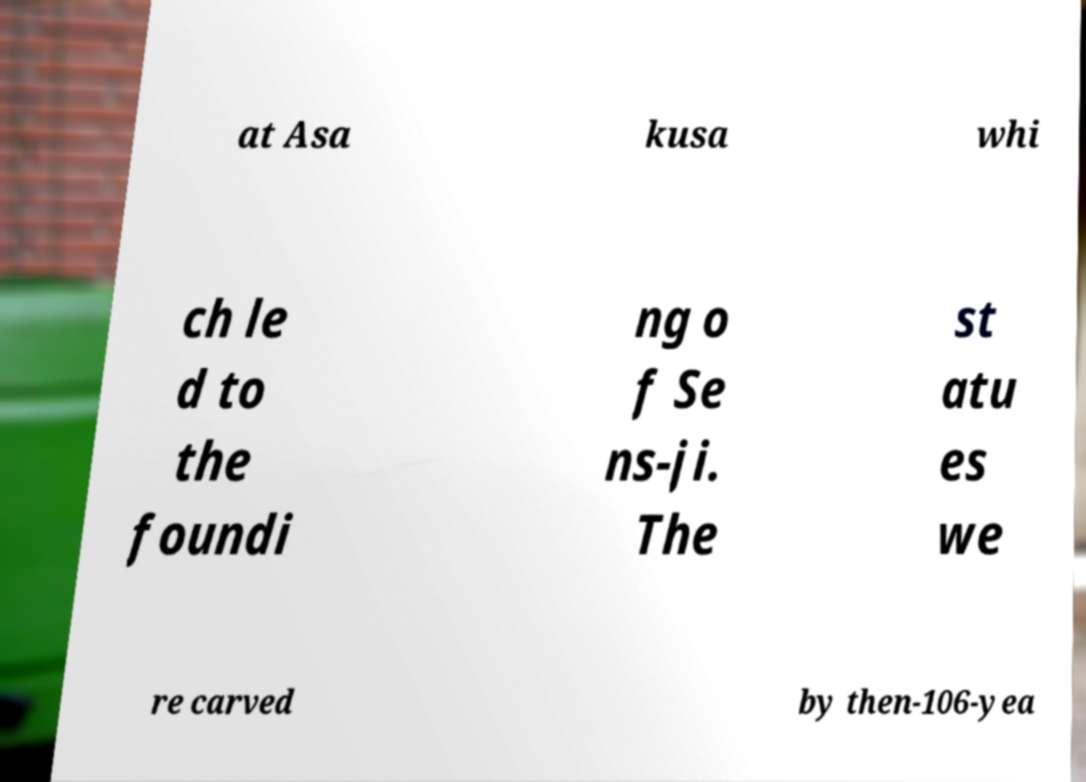Can you accurately transcribe the text from the provided image for me? at Asa kusa whi ch le d to the foundi ng o f Se ns-ji. The st atu es we re carved by then-106-yea 